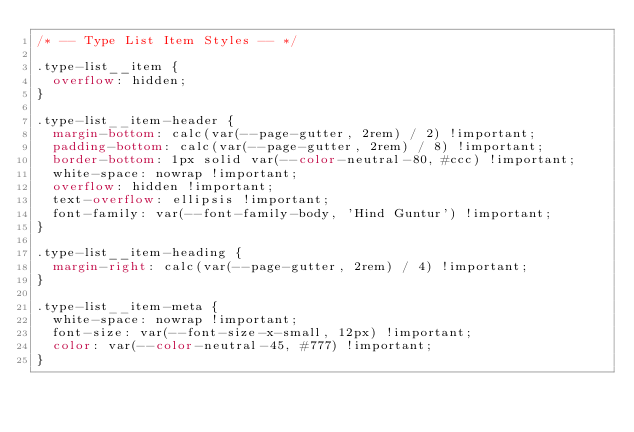<code> <loc_0><loc_0><loc_500><loc_500><_CSS_>/* -- Type List Item Styles -- */

.type-list__item {
  overflow: hidden;
}

.type-list__item-header {
  margin-bottom: calc(var(--page-gutter, 2rem) / 2) !important;
  padding-bottom: calc(var(--page-gutter, 2rem) / 8) !important;
  border-bottom: 1px solid var(--color-neutral-80, #ccc) !important;
  white-space: nowrap !important;
  overflow: hidden !important;
  text-overflow: ellipsis !important;
  font-family: var(--font-family-body, 'Hind Guntur') !important;
}

.type-list__item-heading {
  margin-right: calc(var(--page-gutter, 2rem) / 4) !important;
}

.type-list__item-meta {
  white-space: nowrap !important;
  font-size: var(--font-size-x-small, 12px) !important;
  color: var(--color-neutral-45, #777) !important;
}
</code> 